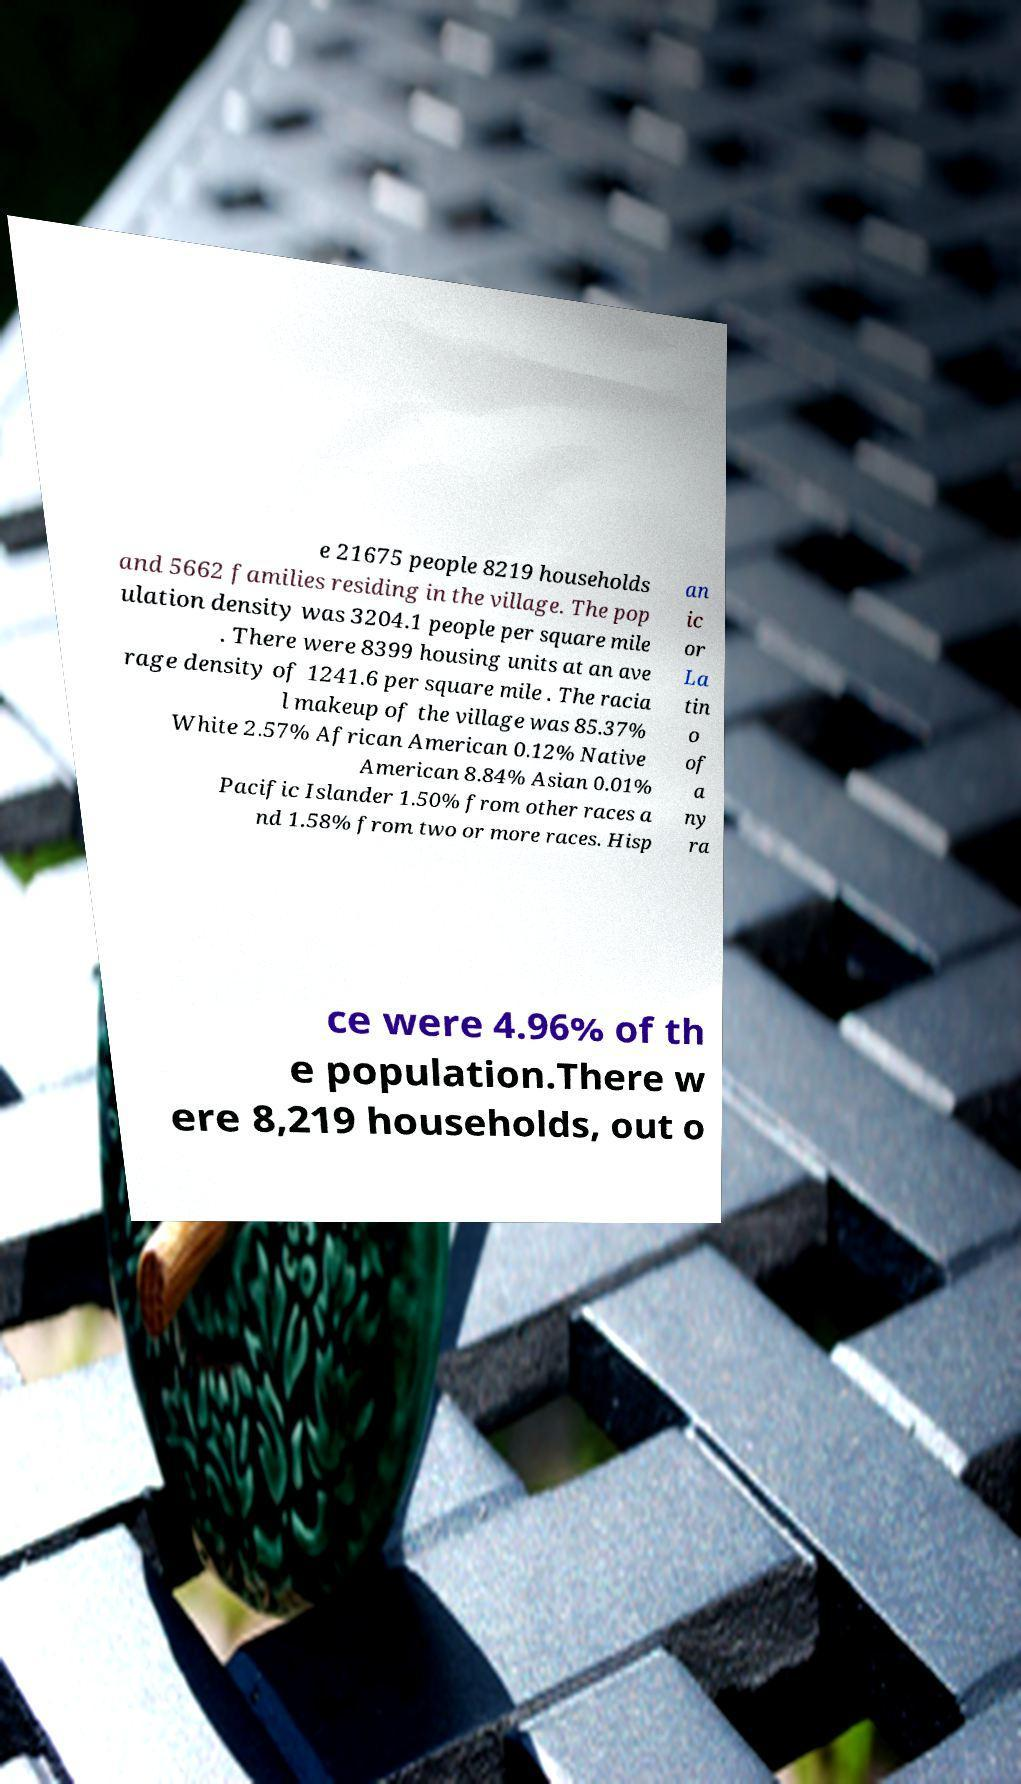Can you read and provide the text displayed in the image?This photo seems to have some interesting text. Can you extract and type it out for me? e 21675 people 8219 households and 5662 families residing in the village. The pop ulation density was 3204.1 people per square mile . There were 8399 housing units at an ave rage density of 1241.6 per square mile . The racia l makeup of the village was 85.37% White 2.57% African American 0.12% Native American 8.84% Asian 0.01% Pacific Islander 1.50% from other races a nd 1.58% from two or more races. Hisp an ic or La tin o of a ny ra ce were 4.96% of th e population.There w ere 8,219 households, out o 